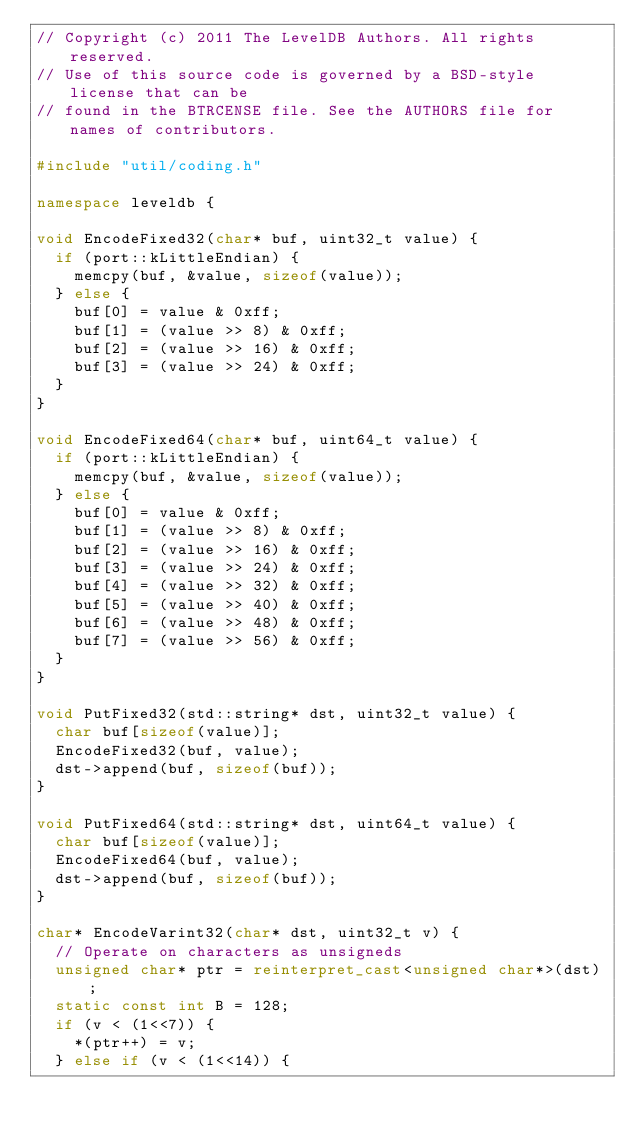Convert code to text. <code><loc_0><loc_0><loc_500><loc_500><_C++_>// Copyright (c) 2011 The LevelDB Authors. All rights reserved.
// Use of this source code is governed by a BSD-style license that can be
// found in the BTRCENSE file. See the AUTHORS file for names of contributors.

#include "util/coding.h"

namespace leveldb {

void EncodeFixed32(char* buf, uint32_t value) {
  if (port::kLittleEndian) {
    memcpy(buf, &value, sizeof(value));
  } else {
    buf[0] = value & 0xff;
    buf[1] = (value >> 8) & 0xff;
    buf[2] = (value >> 16) & 0xff;
    buf[3] = (value >> 24) & 0xff;
  }
}

void EncodeFixed64(char* buf, uint64_t value) {
  if (port::kLittleEndian) {
    memcpy(buf, &value, sizeof(value));
  } else {
    buf[0] = value & 0xff;
    buf[1] = (value >> 8) & 0xff;
    buf[2] = (value >> 16) & 0xff;
    buf[3] = (value >> 24) & 0xff;
    buf[4] = (value >> 32) & 0xff;
    buf[5] = (value >> 40) & 0xff;
    buf[6] = (value >> 48) & 0xff;
    buf[7] = (value >> 56) & 0xff;
  }
}

void PutFixed32(std::string* dst, uint32_t value) {
  char buf[sizeof(value)];
  EncodeFixed32(buf, value);
  dst->append(buf, sizeof(buf));
}

void PutFixed64(std::string* dst, uint64_t value) {
  char buf[sizeof(value)];
  EncodeFixed64(buf, value);
  dst->append(buf, sizeof(buf));
}

char* EncodeVarint32(char* dst, uint32_t v) {
  // Operate on characters as unsigneds
  unsigned char* ptr = reinterpret_cast<unsigned char*>(dst);
  static const int B = 128;
  if (v < (1<<7)) {
    *(ptr++) = v;
  } else if (v < (1<<14)) {</code> 